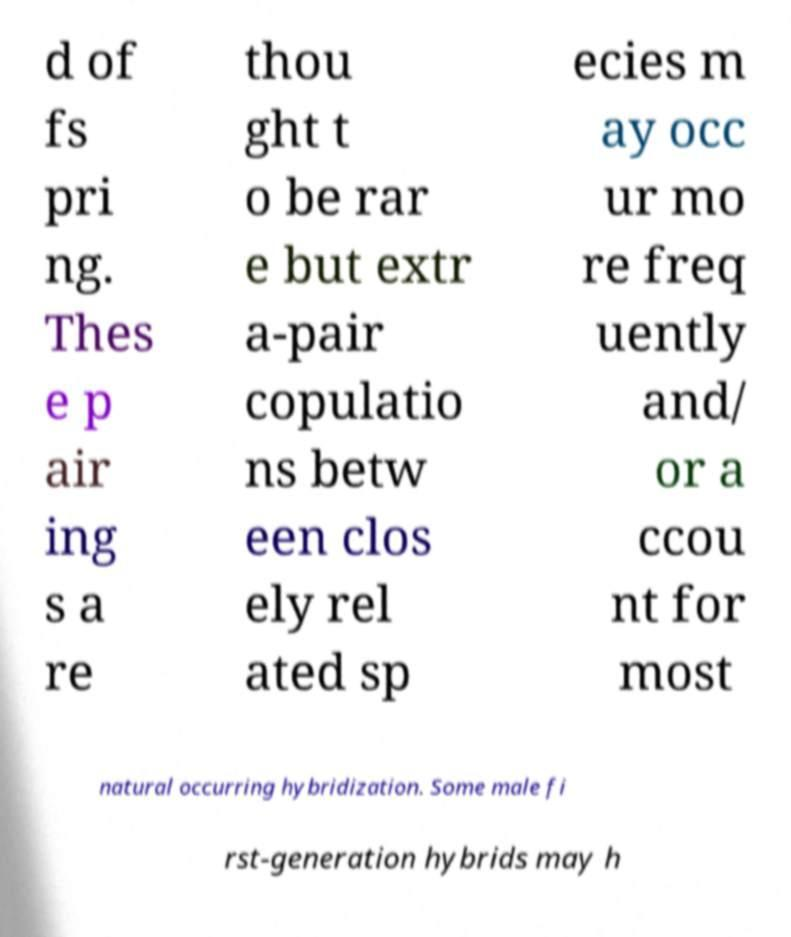Could you extract and type out the text from this image? d of fs pri ng. Thes e p air ing s a re thou ght t o be rar e but extr a-pair copulatio ns betw een clos ely rel ated sp ecies m ay occ ur mo re freq uently and/ or a ccou nt for most natural occurring hybridization. Some male fi rst-generation hybrids may h 